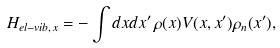Convert formula to latex. <formula><loc_0><loc_0><loc_500><loc_500>H _ { e l - v i b , x } = - \int d x d x ^ { \prime } \, \rho ( x ) V ( x , x ^ { \prime } ) \rho _ { n } ( x ^ { \prime } ) ,</formula> 